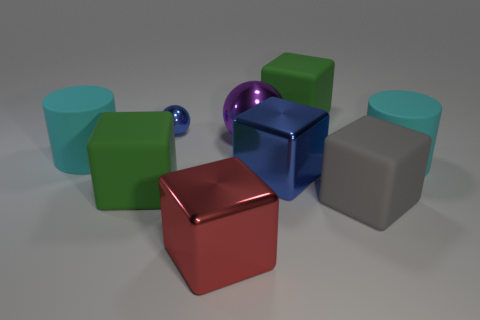What size is the other metallic object that is the same color as the small object?
Provide a short and direct response. Large. What number of things are metal spheres or large green blocks that are in front of the small blue shiny sphere?
Ensure brevity in your answer.  3. Is there a large brown object that has the same material as the tiny ball?
Offer a terse response. No. What number of large cubes are both behind the large gray cube and in front of the purple sphere?
Your answer should be very brief. 2. What is the material of the blue object that is in front of the large sphere?
Offer a very short reply. Metal. What is the size of the blue sphere that is made of the same material as the large red block?
Offer a terse response. Small. Are there any big green matte things right of the gray cube?
Give a very brief answer. No. There is a blue metal thing that is the same shape as the big purple object; what size is it?
Make the answer very short. Small. There is a tiny metallic sphere; is its color the same as the matte block that is behind the purple thing?
Offer a terse response. No. Is the tiny metallic ball the same color as the big shiny sphere?
Provide a succinct answer. No. 